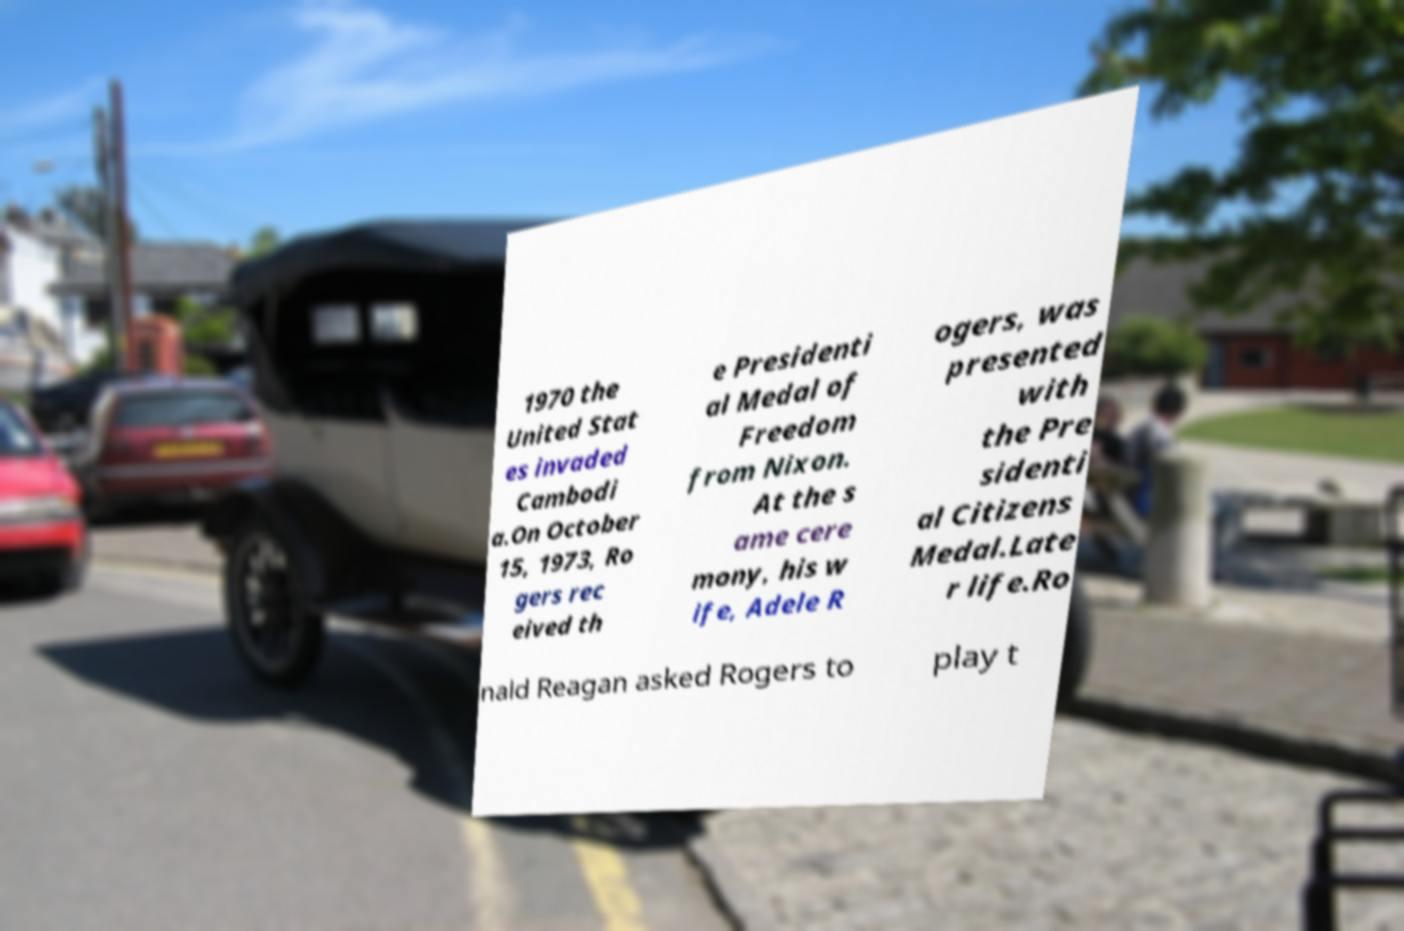I need the written content from this picture converted into text. Can you do that? 1970 the United Stat es invaded Cambodi a.On October 15, 1973, Ro gers rec eived th e Presidenti al Medal of Freedom from Nixon. At the s ame cere mony, his w ife, Adele R ogers, was presented with the Pre sidenti al Citizens Medal.Late r life.Ro nald Reagan asked Rogers to play t 